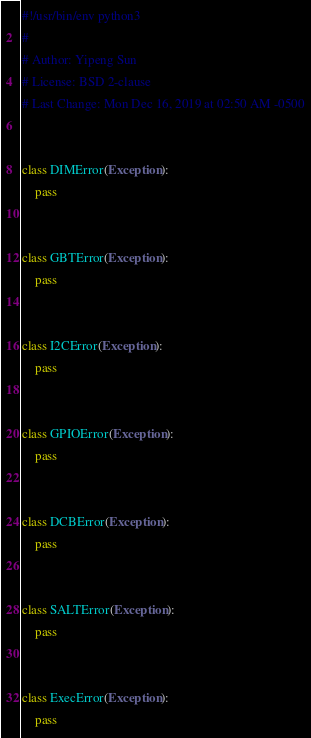Convert code to text. <code><loc_0><loc_0><loc_500><loc_500><_Python_>#!/usr/bin/env python3
#
# Author: Yipeng Sun
# License: BSD 2-clause
# Last Change: Mon Dec 16, 2019 at 02:50 AM -0500


class DIMError(Exception):
    pass


class GBTError(Exception):
    pass


class I2CError(Exception):
    pass


class GPIOError(Exception):
    pass


class DCBError(Exception):
    pass


class SALTError(Exception):
    pass


class ExecError(Exception):
    pass
</code> 